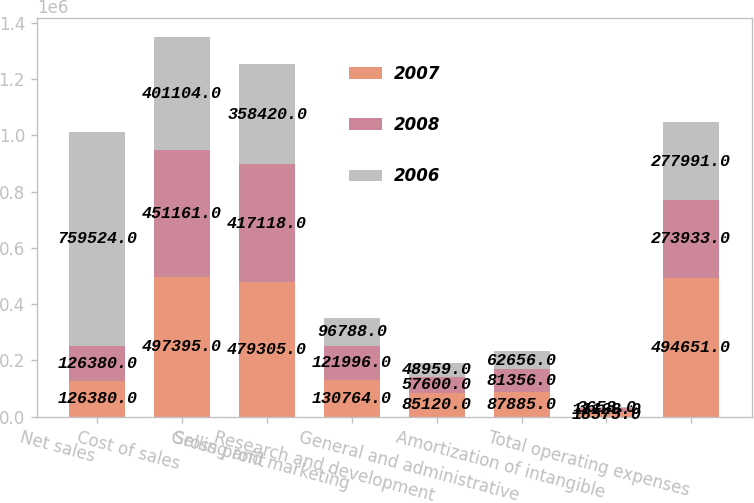<chart> <loc_0><loc_0><loc_500><loc_500><stacked_bar_chart><ecel><fcel>Net sales<fcel>Cost of sales<fcel>Gross profit<fcel>Selling and marketing<fcel>Research and development<fcel>General and administrative<fcel>Amortization of intangible<fcel>Total operating expenses<nl><fcel>2007<fcel>126380<fcel>497395<fcel>479305<fcel>130764<fcel>85120<fcel>87885<fcel>18575<fcel>494651<nl><fcel>2008<fcel>126380<fcel>451161<fcel>417118<fcel>121996<fcel>57600<fcel>81356<fcel>11128<fcel>273933<nl><fcel>2006<fcel>759524<fcel>401104<fcel>358420<fcel>96788<fcel>48959<fcel>62656<fcel>3653<fcel>277991<nl></chart> 